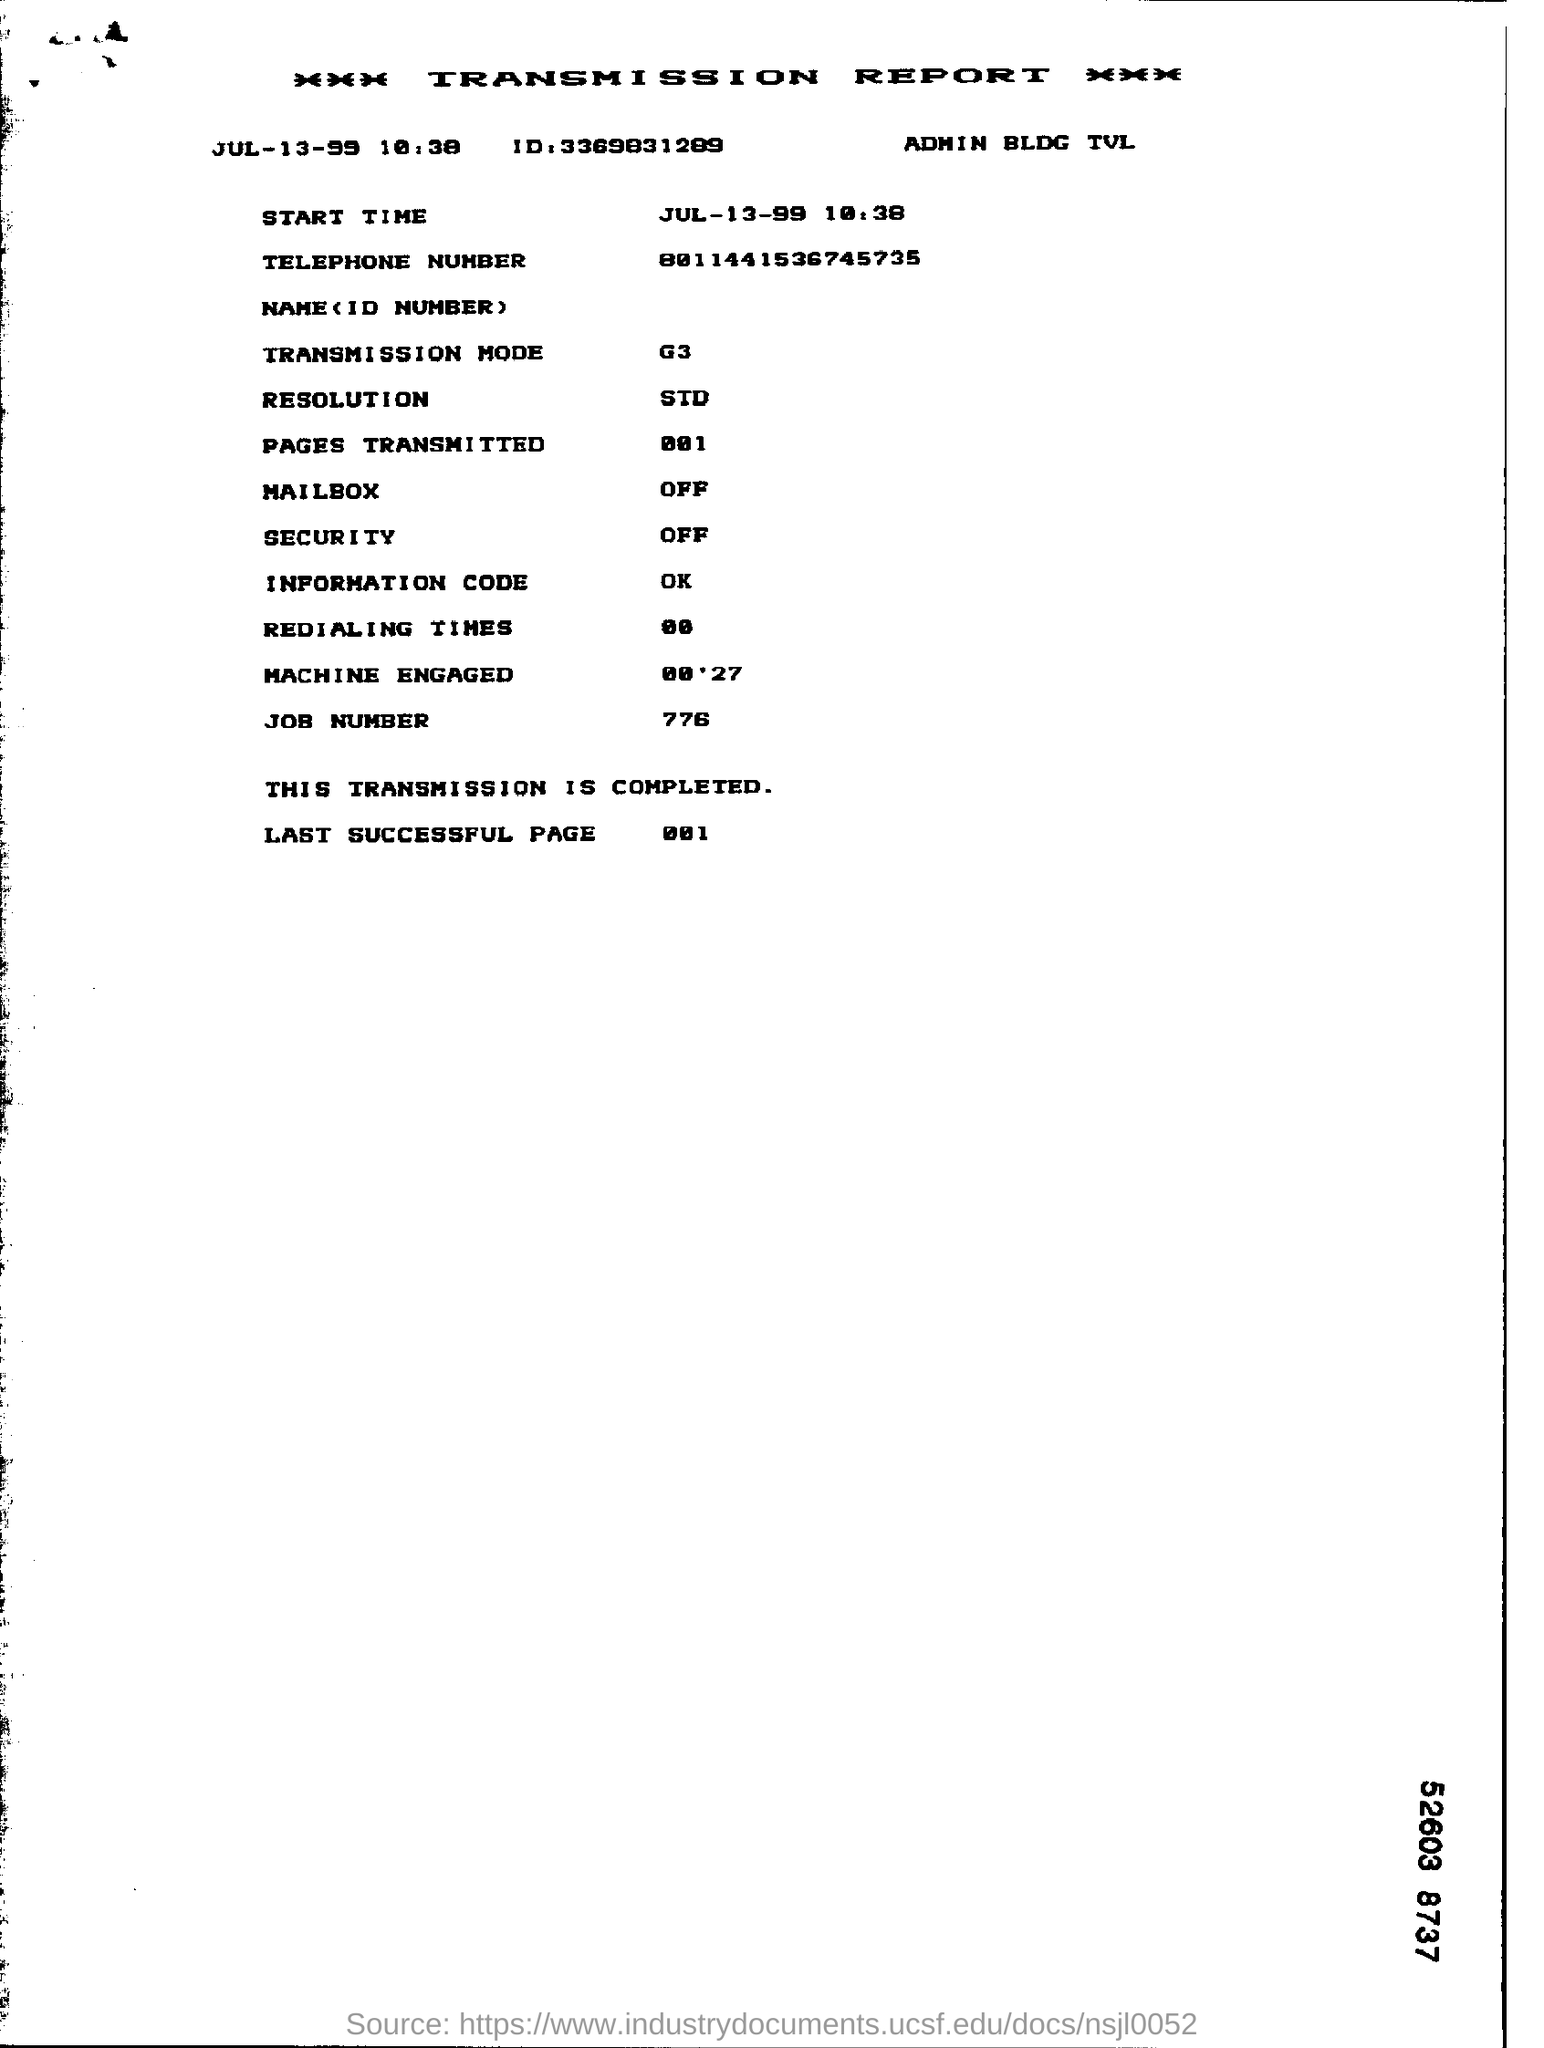When is the transmission report dated?
Your answer should be compact. Jul-13-99. What is the transmission mode mentioned in the report?
Provide a short and direct response. G3. What is the resolution mentioned in the report?
Make the answer very short. STD. What is the status of the transmission report?
Provide a succinct answer. Completed. What is the job number mentioned in the report?
Provide a succinct answer. 776. 